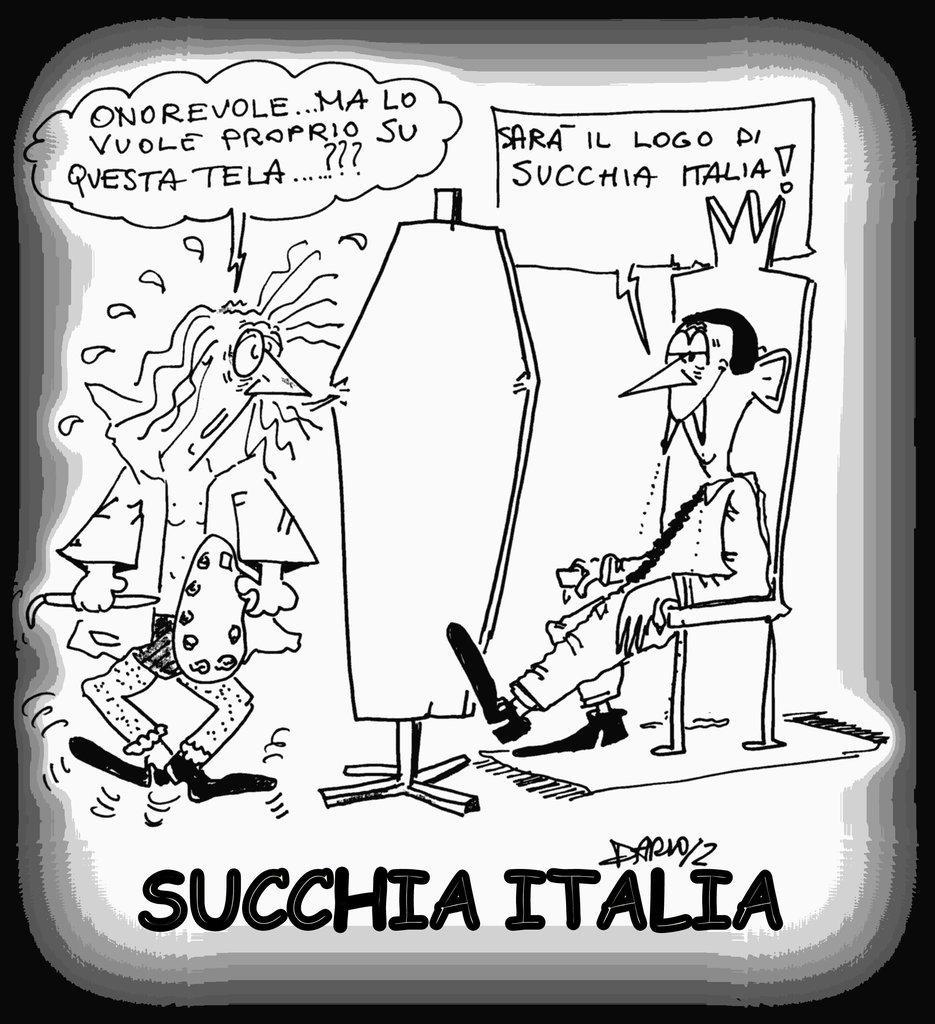How would you summarize this image in a sentence or two? This is a poster and in this poster we can see man sitting on a chair and some text. 